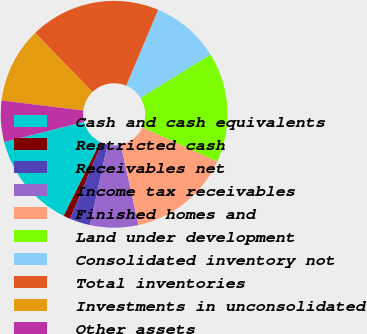<chart> <loc_0><loc_0><loc_500><loc_500><pie_chart><fcel>Cash and cash equivalents<fcel>Restricted cash<fcel>Receivables net<fcel>Income tax receivables<fcel>Finished homes and<fcel>Land under development<fcel>Consolidated inventory not<fcel>Total inventories<fcel>Investments in unconsolidated<fcel>Other assets<nl><fcel>13.72%<fcel>0.98%<fcel>2.94%<fcel>6.86%<fcel>14.7%<fcel>15.68%<fcel>9.8%<fcel>18.62%<fcel>10.78%<fcel>5.88%<nl></chart> 